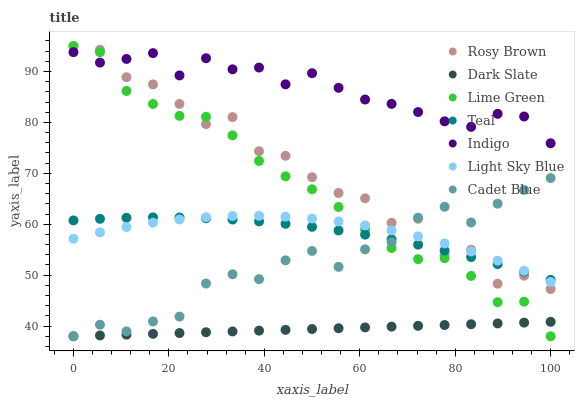Does Dark Slate have the minimum area under the curve?
Answer yes or no. Yes. Does Indigo have the maximum area under the curve?
Answer yes or no. Yes. Does Rosy Brown have the minimum area under the curve?
Answer yes or no. No. Does Rosy Brown have the maximum area under the curve?
Answer yes or no. No. Is Dark Slate the smoothest?
Answer yes or no. Yes. Is Rosy Brown the roughest?
Answer yes or no. Yes. Is Indigo the smoothest?
Answer yes or no. No. Is Indigo the roughest?
Answer yes or no. No. Does Cadet Blue have the lowest value?
Answer yes or no. Yes. Does Rosy Brown have the lowest value?
Answer yes or no. No. Does Lime Green have the highest value?
Answer yes or no. Yes. Does Indigo have the highest value?
Answer yes or no. No. Is Light Sky Blue less than Indigo?
Answer yes or no. Yes. Is Rosy Brown greater than Dark Slate?
Answer yes or no. Yes. Does Cadet Blue intersect Lime Green?
Answer yes or no. Yes. Is Cadet Blue less than Lime Green?
Answer yes or no. No. Is Cadet Blue greater than Lime Green?
Answer yes or no. No. Does Light Sky Blue intersect Indigo?
Answer yes or no. No. 